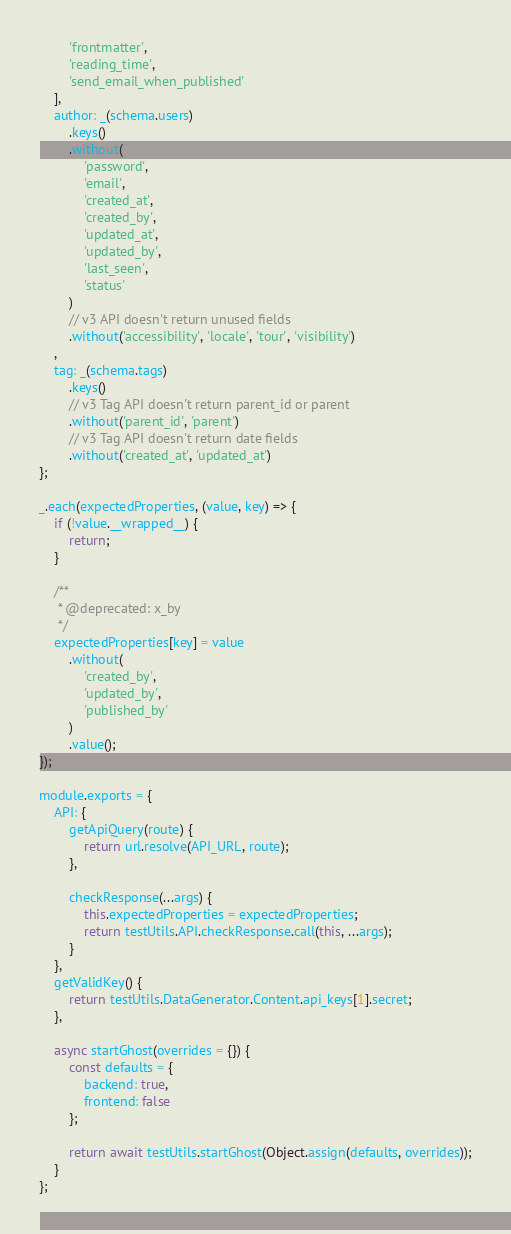Convert code to text. <code><loc_0><loc_0><loc_500><loc_500><_JavaScript_>        'frontmatter',
        'reading_time',
        'send_email_when_published'
    ],
    author: _(schema.users)
        .keys()
        .without(
            'password',
            'email',
            'created_at',
            'created_by',
            'updated_at',
            'updated_by',
            'last_seen',
            'status'
        )
        // v3 API doesn't return unused fields
        .without('accessibility', 'locale', 'tour', 'visibility')
    ,
    tag: _(schema.tags)
        .keys()
        // v3 Tag API doesn't return parent_id or parent
        .without('parent_id', 'parent')
        // v3 Tag API doesn't return date fields
        .without('created_at', 'updated_at')
};

_.each(expectedProperties, (value, key) => {
    if (!value.__wrapped__) {
        return;
    }

    /**
     * @deprecated: x_by
     */
    expectedProperties[key] = value
        .without(
            'created_by',
            'updated_by',
            'published_by'
        )
        .value();
});

module.exports = {
    API: {
        getApiQuery(route) {
            return url.resolve(API_URL, route);
        },

        checkResponse(...args) {
            this.expectedProperties = expectedProperties;
            return testUtils.API.checkResponse.call(this, ...args);
        }
    },
    getValidKey() {
        return testUtils.DataGenerator.Content.api_keys[1].secret;
    },

    async startGhost(overrides = {}) {
        const defaults = {
            backend: true,
            frontend: false
        };

        return await testUtils.startGhost(Object.assign(defaults, overrides));
    }
};
</code> 